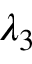<formula> <loc_0><loc_0><loc_500><loc_500>\lambda _ { 3 }</formula> 